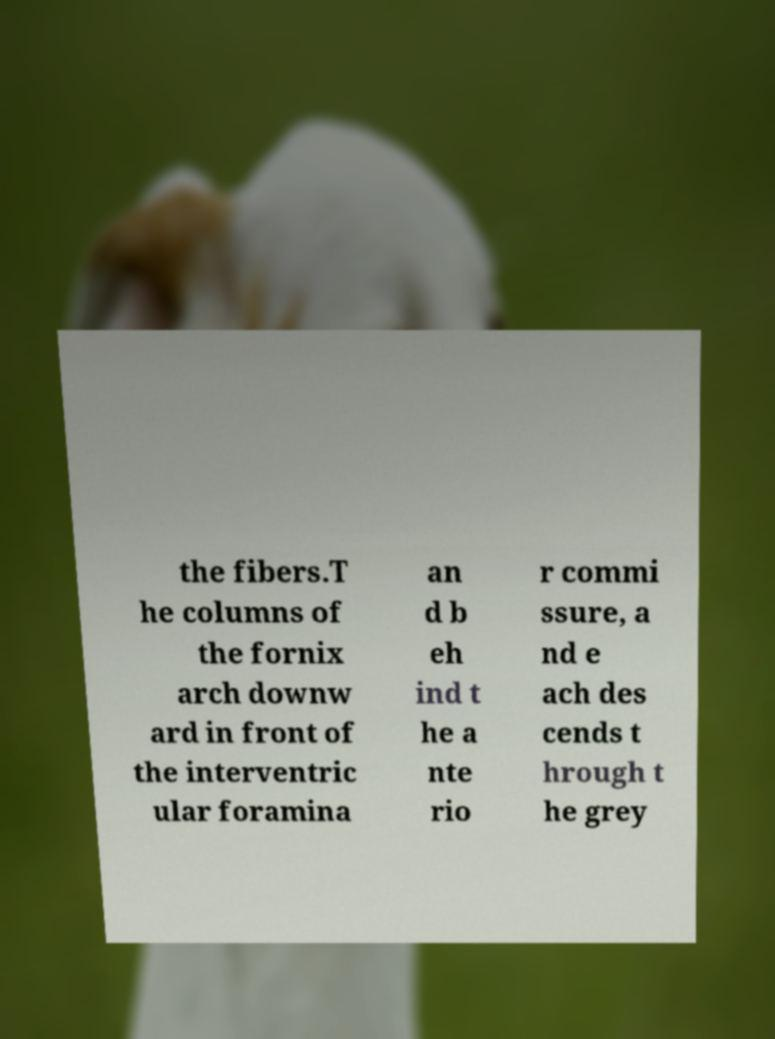For documentation purposes, I need the text within this image transcribed. Could you provide that? the fibers.T he columns of the fornix arch downw ard in front of the interventric ular foramina an d b eh ind t he a nte rio r commi ssure, a nd e ach des cends t hrough t he grey 